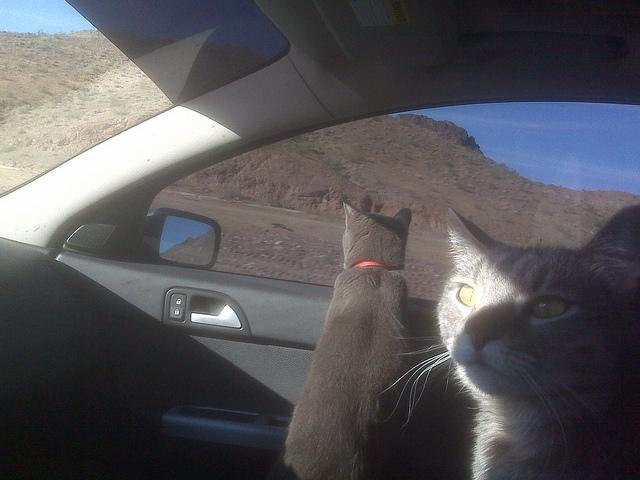Which section of the car is the cat by the window sitting at? passenger seat 